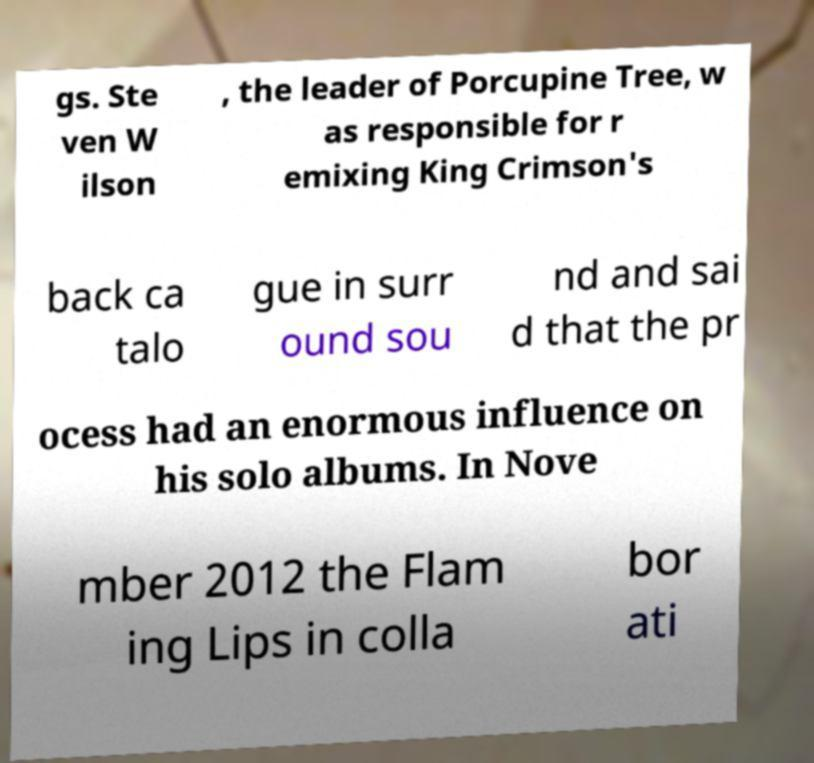What messages or text are displayed in this image? I need them in a readable, typed format. gs. Ste ven W ilson , the leader of Porcupine Tree, w as responsible for r emixing King Crimson's back ca talo gue in surr ound sou nd and sai d that the pr ocess had an enormous influence on his solo albums. In Nove mber 2012 the Flam ing Lips in colla bor ati 